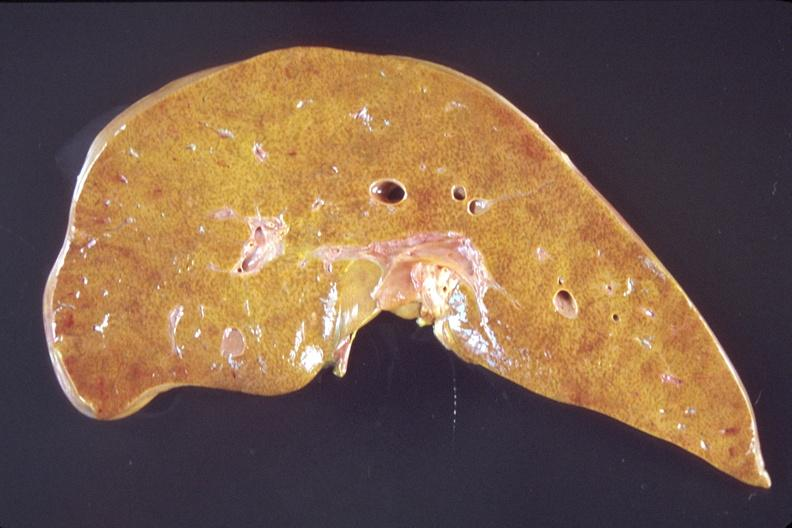does abruption show liver, early chronic passive congestion?
Answer the question using a single word or phrase. No 